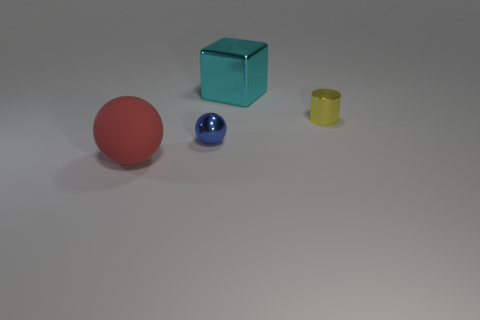There is a ball that is behind the thing in front of the blue shiny ball; how many yellow objects are to the left of it?
Make the answer very short. 0. There is a small cylinder; are there any rubber objects in front of it?
Offer a very short reply. Yes. What number of other objects are the same size as the shiny block?
Your response must be concise. 1. Is the shape of the tiny object in front of the small cylinder the same as the big object in front of the large cyan metallic object?
Provide a short and direct response. Yes. Is there any other thing that has the same material as the large red ball?
Ensure brevity in your answer.  No. There is a tiny thing that is behind the shiny thing in front of the metal object that is on the right side of the cyan shiny object; what is its shape?
Make the answer very short. Cylinder. What number of other things are there of the same shape as the red object?
Offer a terse response. 1. There is a shiny block that is the same size as the matte sphere; what is its color?
Provide a succinct answer. Cyan. What number of spheres are either tiny blue shiny objects or cyan metal objects?
Keep it short and to the point. 1. How many green rubber things are there?
Your answer should be compact. 0. 